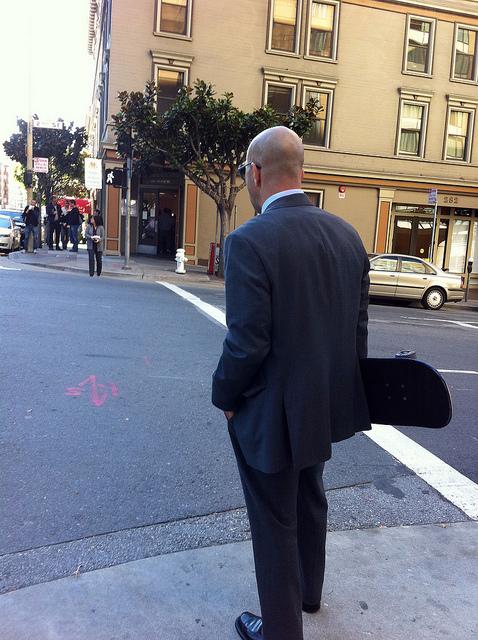Is the man moving?
Write a very short answer. No. Does the man have an injured arm?
Short answer required. No. What is the man in the suit carrying?
Be succinct. Skateboard. What color is The man's collar of his shirt under his suit?
Write a very short answer. White. Where is the man standing?
Quick response, please. Sidewalk. 